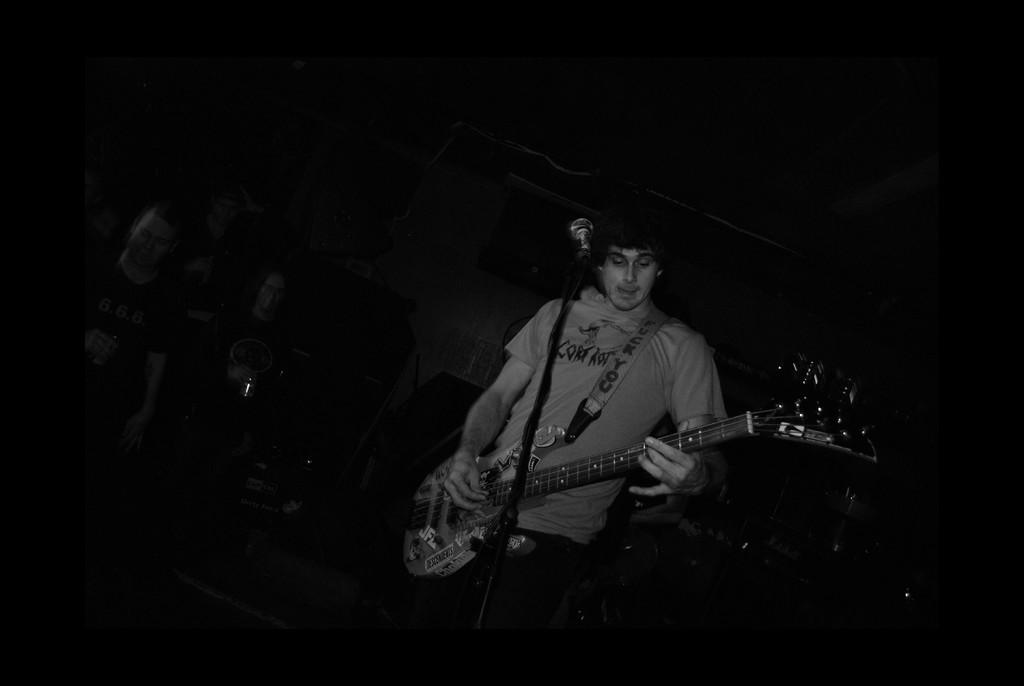Who is the main subject in the image? There is a man in the image. What is the man holding in the image? The man is holding a guitar. What object is the man standing in front of? The man is standing in front of a microphone. What riddle is the man trying to solve in the image? There is no riddle present in the image; the man is holding a guitar and standing in front of a microphone. 